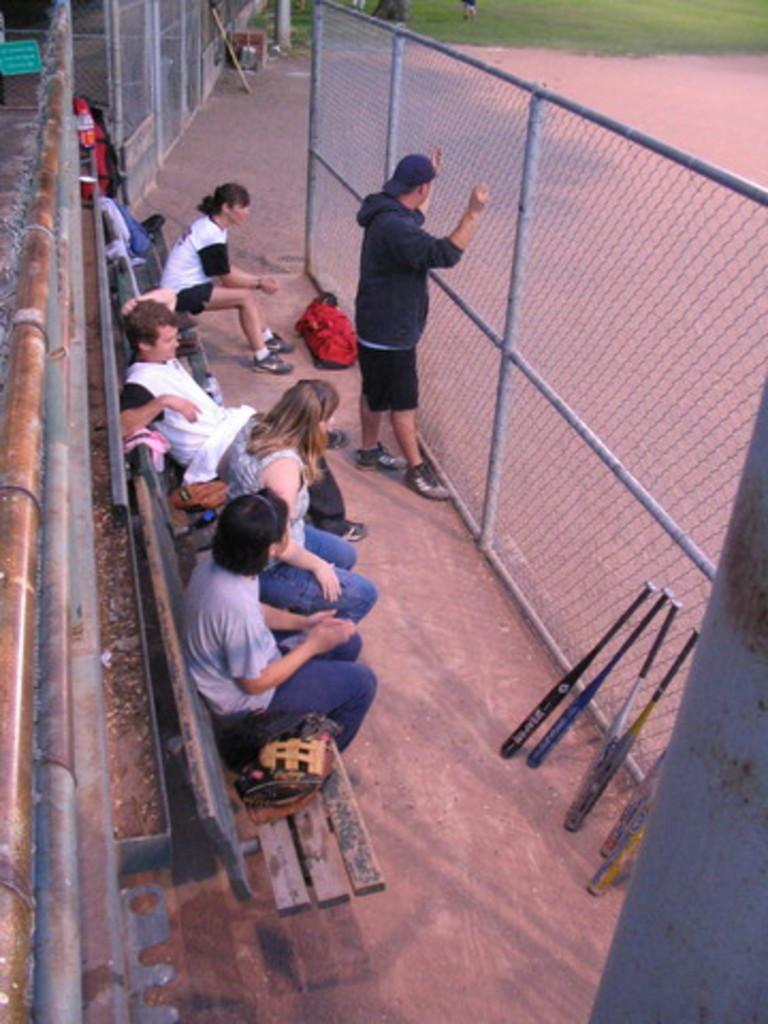What are the people in the image doing? The people in the image are sitting on a bench. What is the bench situated near? The bench is behind a fence. What objects are hanging on the fence? Baseball bats are hanging on the fence. What type of landscape is visible in the background of the image? Grassland is visible in the background of the image and mention the presence of another element, which is the baseball bats. Can you describe the setting where the bench is located? The bench is located near a fence, and there is grassland visible in the background. What type of bridge can be seen in the image? There is no bridge present in the image. Is there a band playing music in the background of the image? There is no band or music playing in the image. 